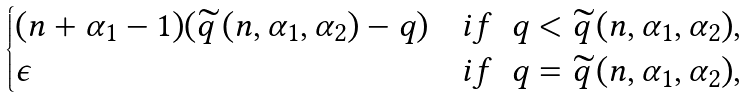Convert formula to latex. <formula><loc_0><loc_0><loc_500><loc_500>\begin{cases} ( n + \alpha _ { 1 } - 1 ) ( \widetilde { q } \, ( n , \alpha _ { 1 } , \alpha _ { 2 } ) - q ) & i f \ \ q < \widetilde { q } \, ( n , \alpha _ { 1 } , \alpha _ { 2 } ) , \\ \epsilon & i f \ \ q = \widetilde { q } \, ( n , \alpha _ { 1 } , \alpha _ { 2 } ) , \end{cases}</formula> 